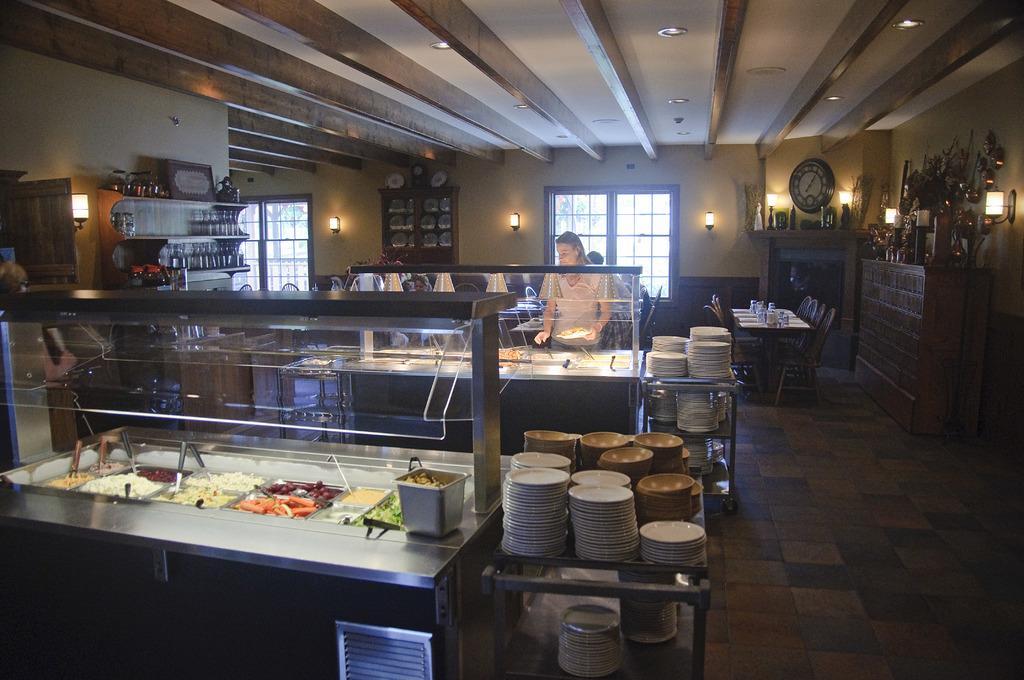How would you summarize this image in a sentence or two? In this picture, we can see a few people, and some tables and some objects on it like plates, bowls and we can see some chairs, we can see the walls with windows, clock, lights and some objects attached to it, we can see the door and the roof with lights, ceiling. 